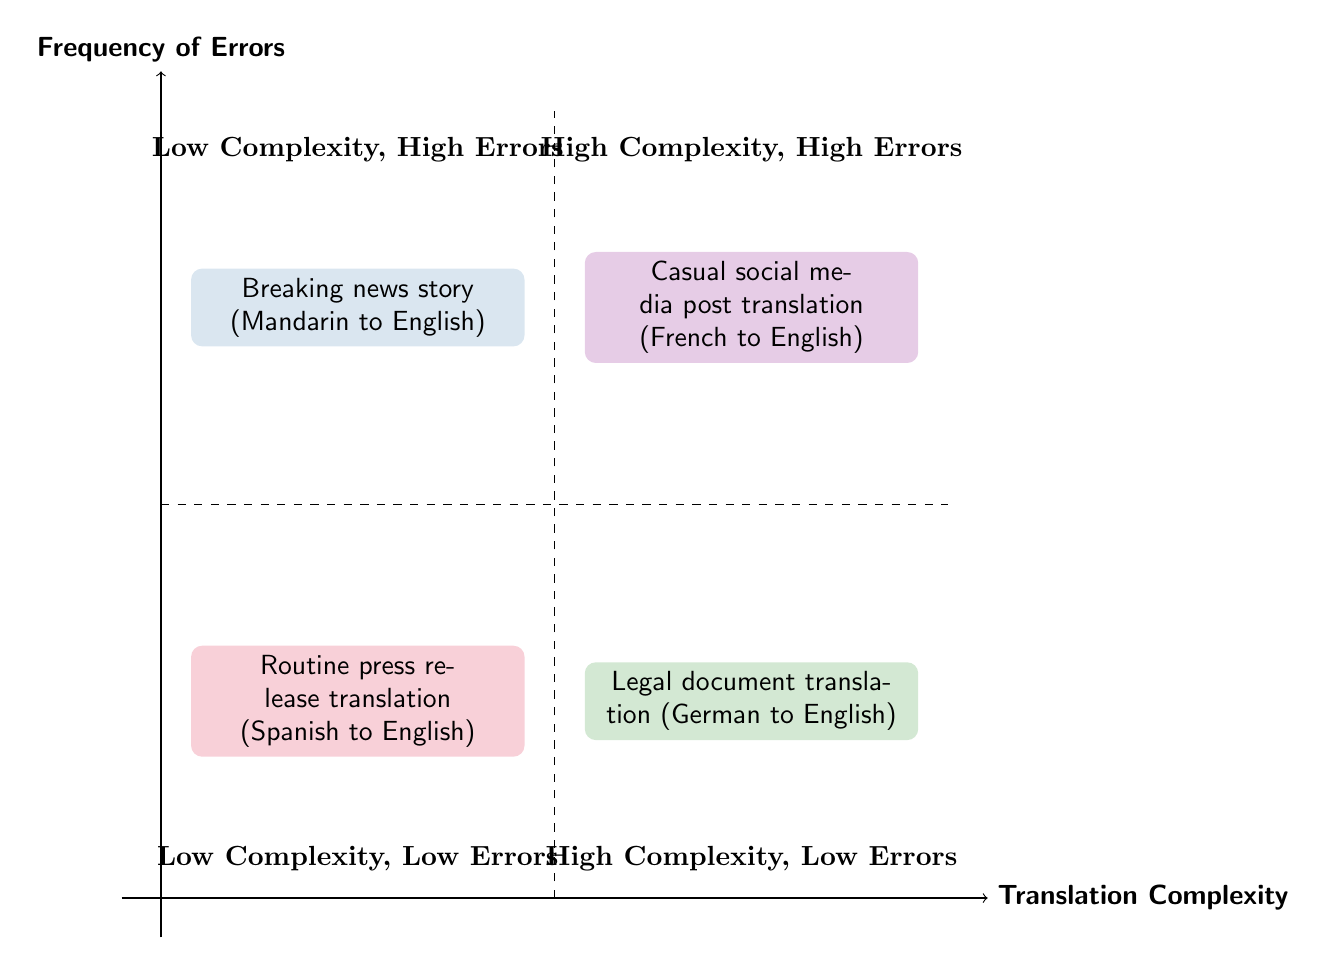What is the example for high translation complexity and high frequency of errors? The diagram indicates that a breaking news story that requires immediate translation from Mandarin to English has high translation complexity and high frequency of errors.
Answer: Breaking news story (Mandarin to English) What type of translation shows low complexity and low frequency of errors? The diagram shows that a routine press release translation from Spanish to English has low complexity and low frequency of errors.
Answer: Routine press release translation (Spanish to English) How many types of translations are represented in the diagram? There are four distinct translations represented in the diagram, each located in different quadrants based on their complexity and frequency of errors.
Answer: 4 Which example has high complexity but low frequency of errors? The diagram specifies that a legal document translation from German to English has high complexity while exhibiting low frequency of errors, as indicated by its placement in the respective quadrant.
Answer: Legal document translation (German to English) Which quadrant has examples of translations with low complexity? The bottom quadrants represent low complexity translations; specifically, the quadrant located in the lower left contains a routine press release, while the lower right quadrant is where casual social media posts are found.
Answer: Lower left and lower right quadrants What is common between the high complexity, high errors section and the low complexity, high errors section? Both sections contain translations that exhibit a high frequency of errors; they differ mainly in their complexity, with one being high in complexity and the other low.
Answer: High frequency of errors How would you categorize a casual social media post translation in terms of complexity and error frequency? The diagram places a casual social media post translation from French to English in the quadrant marked as low complexity and high frequency of errors, indicating it has a simpler structure but often leads to mistakes.
Answer: Low complexity, high errors Which quadrant represents transactions with low errors? The top quadrants of the diagram represent translations with low frequency of errors, specifically where high complexity is noted on the right and low complexity on the left.
Answer: Top quadrants 